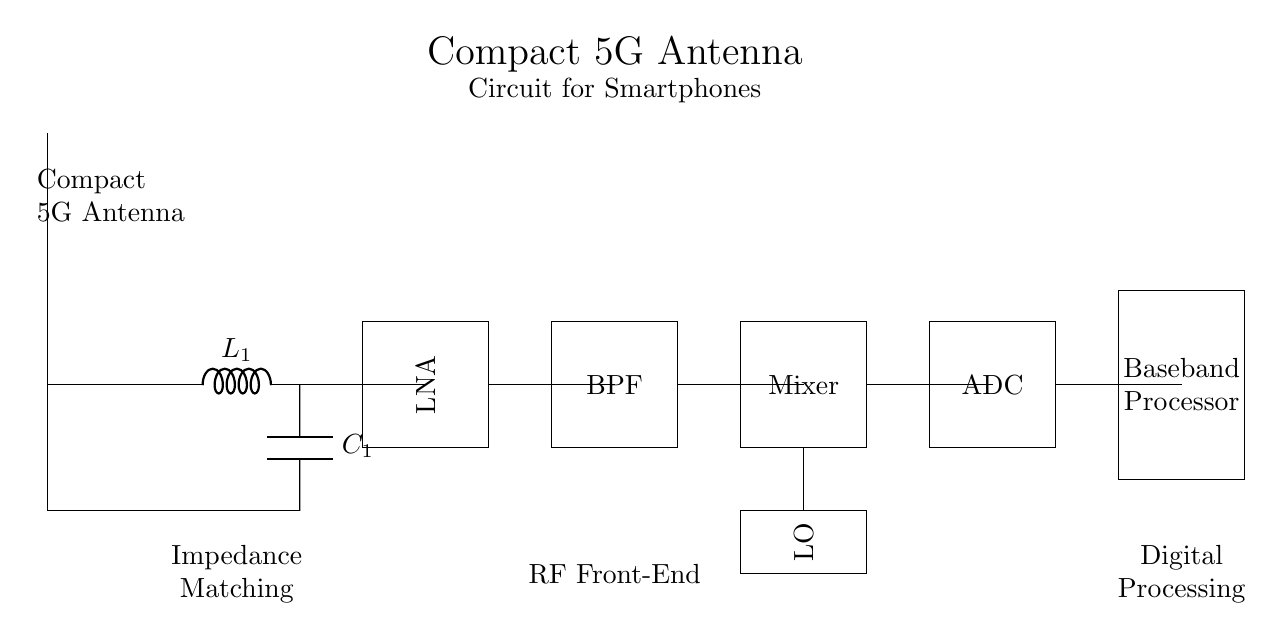What type of antenna is shown in the circuit? The diagram depicts a compact antenna design, which is specifically labeled as a "Compact 5G Antenna." This is evidenced by the main component shown at the top of the circuit.
Answer: Compact 5G Antenna What component follows the antenna in the circuit? After the antenna in the circuit, there is a matching network consisting of an inductor and a capacitor, as seen in the lower section labeled "Impedance Matching."
Answer: Impedance Matching How many main functional blocks are in the circuit? The circuit contains six main functional blocks: the antenna, matching network, LNA, BPF, Mixer, and Baseband Processor. Each block serves a specific function in the signal processing chain.
Answer: Six What is the role of the LNA in this circuit? The LNA, which stands for Low Noise Amplifier, is responsible for amplifying the weak signals received by the antenna. It is a crucial component for improving the signal quality before further processing.
Answer: Amplifying weak signals What does BPF stand for in this circuit? In the circuit, BPF stands for Band Pass Filter, which is utilized to allow signals within a specific frequency range to pass while attenuating signals outside that range. This is critical for ensuring that only the desired frequencies are processed.
Answer: Band Pass Filter What does LO represent in the context of this circuit? LO represents Local Oscillator, which is used in conjunction with the mixer to convert signal frequencies to lower intermediate frequencies for further processing in communication systems.
Answer: Local Oscillator 